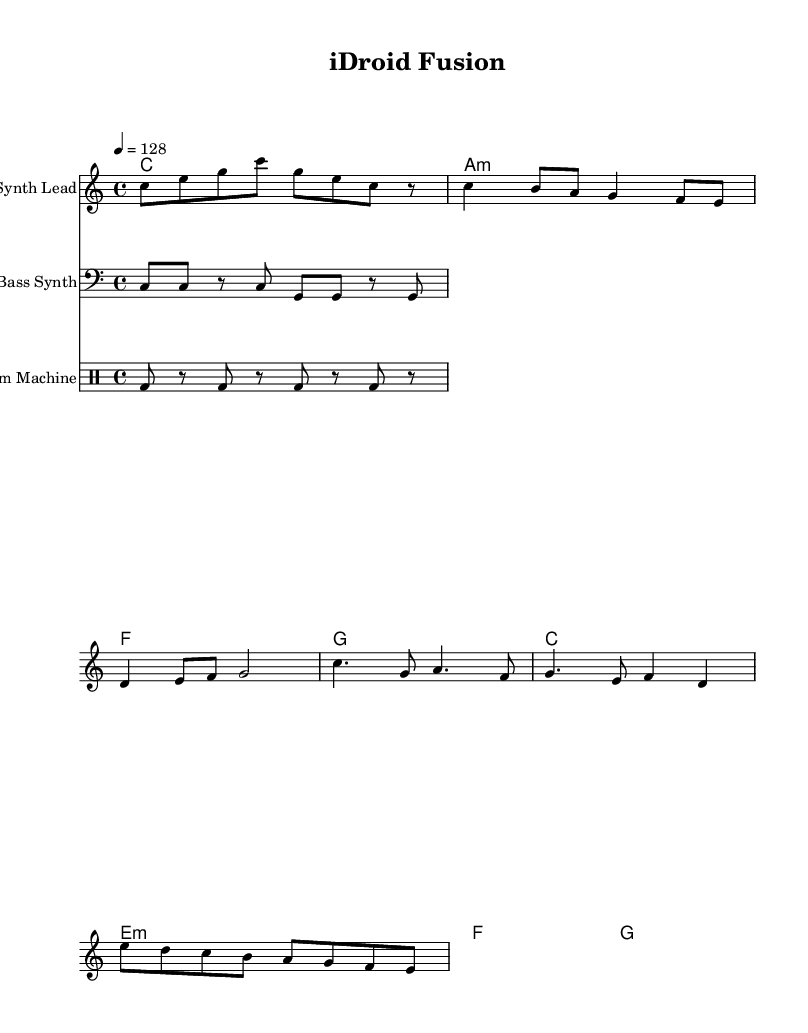What is the key signature of this music? The key signature is indicated by the absence of sharps or flats at the beginning of the staff, which designates the key as C major.
Answer: C major What is the time signature of this piece? The time signature is given in the initial part of the score, which shows a 4/4 time signature, indicating there are four beats in each measure.
Answer: 4/4 What is the tempo marking of this music? The tempo marking appears at the beginning of the score as "4 = 128", denoting the beats per minute for the piece.
Answer: 128 How many measures are there in the melody section? Counting the melody notes and the corresponding measure lines in the sheet music shows that there are a total of 8 measures in the melody section.
Answer: 8 What chord follows A minor in the harmony? By analyzing the chord progression in the "harmonies" section, the A minor chord is immediately followed by the F major chord.
Answer: F What type of instrument is represented by the "Synth Lead" staff? The label on the staff indicates that it is designated for the "Synth Lead", which is a type of electronic instrument typically used in techno music.
Answer: Synth Lead What is the rhythmic value of the first note in the melody? The first note, "C", is represented as an eighth note in the melody line, shown by the notation with a stem and filled note head.
Answer: Eighth note 